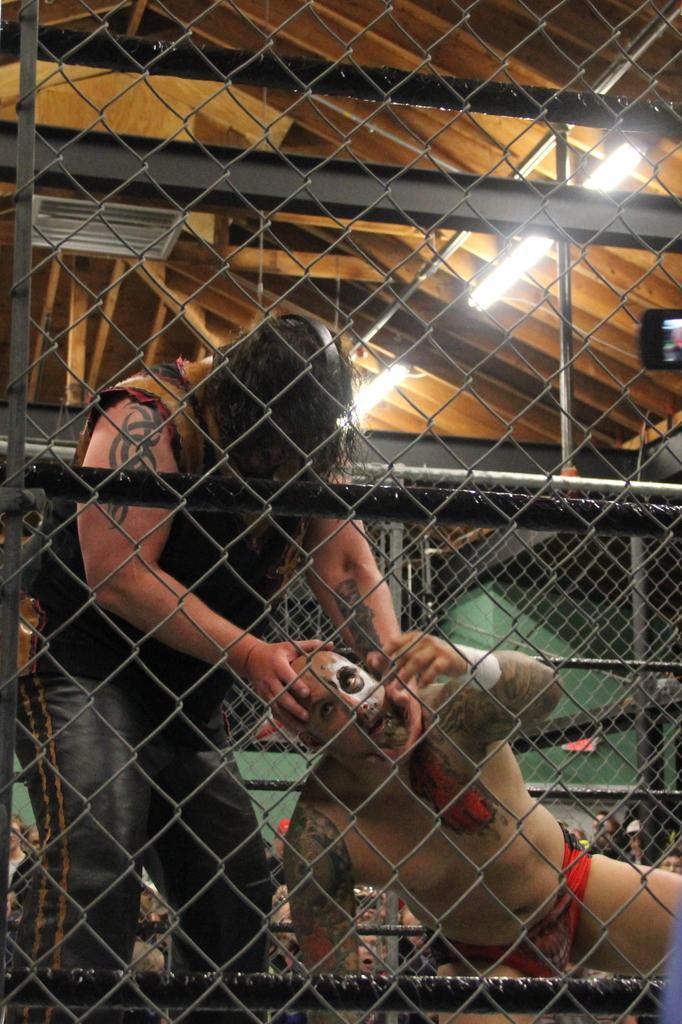Describe this image in one or two sentences. This is a fence and we can see poles. Here there are two men fighting. In the background there are audience,lights on the roof top,on the right we can see a truncated mobile and some other objects. 